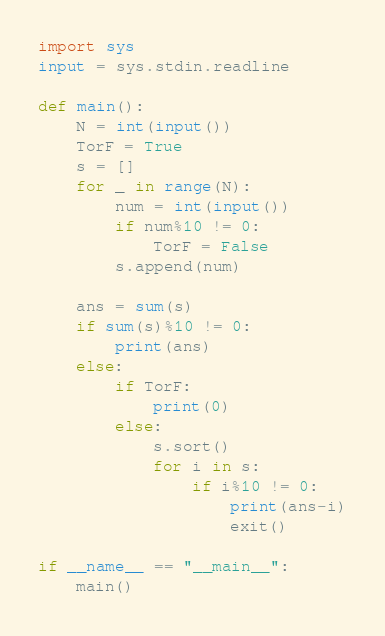<code> <loc_0><loc_0><loc_500><loc_500><_Python_>import sys
input = sys.stdin.readline

def main():
    N = int(input())
    TorF = True
    s = []
    for _ in range(N):
        num = int(input())
        if num%10 != 0:
            TorF = False
        s.append(num)
    
    ans = sum(s)        
    if sum(s)%10 != 0:
        print(ans)
    else:
        if TorF:
            print(0)
        else:
            s.sort()
            for i in s:
                if i%10 != 0:
                    print(ans-i)
                    exit()
    
if __name__ == "__main__":
    main()</code> 